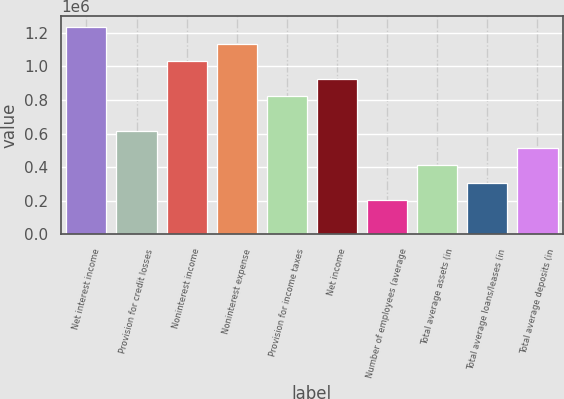<chart> <loc_0><loc_0><loc_500><loc_500><bar_chart><fcel>Net interest income<fcel>Provision for credit losses<fcel>Noninterest income<fcel>Noninterest expense<fcel>Provision for income taxes<fcel>Net income<fcel>Number of employees (average<fcel>Total average assets (in<fcel>Total average loans/leases (in<fcel>Total average deposits (in<nl><fcel>1.23629e+06<fcel>618143<fcel>1.03024e+06<fcel>1.13326e+06<fcel>824190<fcel>927214<fcel>206048<fcel>412095<fcel>309072<fcel>515119<nl></chart> 